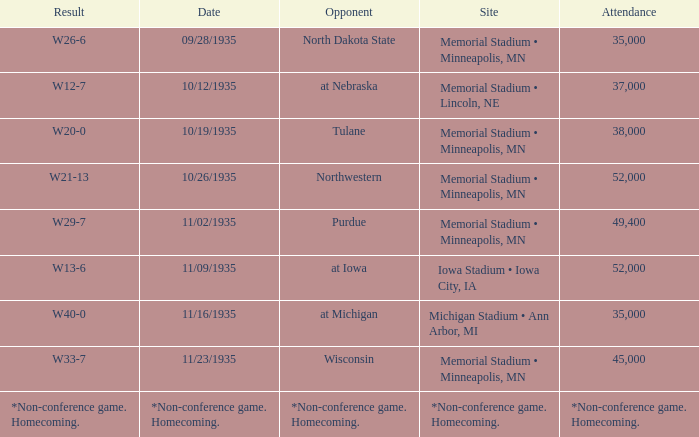Who was the opponent against which the result was w20-0? Tulane. 